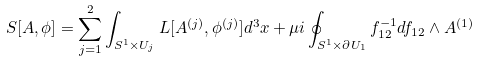<formula> <loc_0><loc_0><loc_500><loc_500>S [ A , \phi ] = \sum _ { j = 1 } ^ { 2 } \int _ { S ^ { 1 } \times U _ { j } } L [ A ^ { ( j ) } , \phi ^ { ( j ) } ] d ^ { 3 } x + \mu i \oint _ { S ^ { 1 } \times \partial U _ { 1 } } f _ { 1 2 } ^ { - 1 } d f _ { 1 2 } \wedge A ^ { ( 1 ) }</formula> 